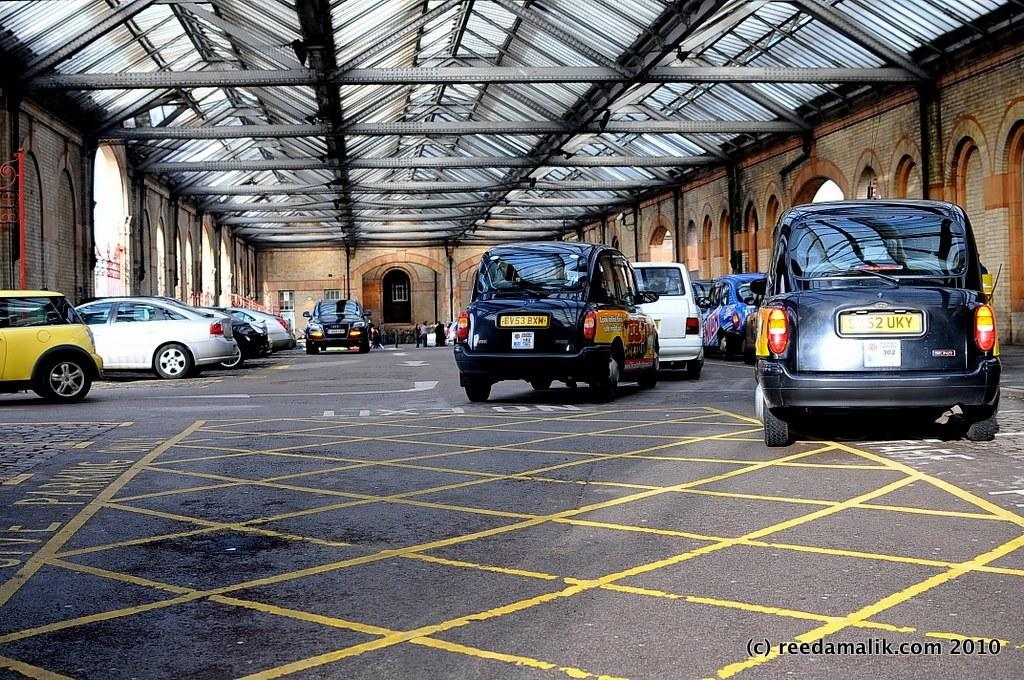<image>
Describe the image concisely. A photo of numerous cars that has a copy write to reeda malik. 